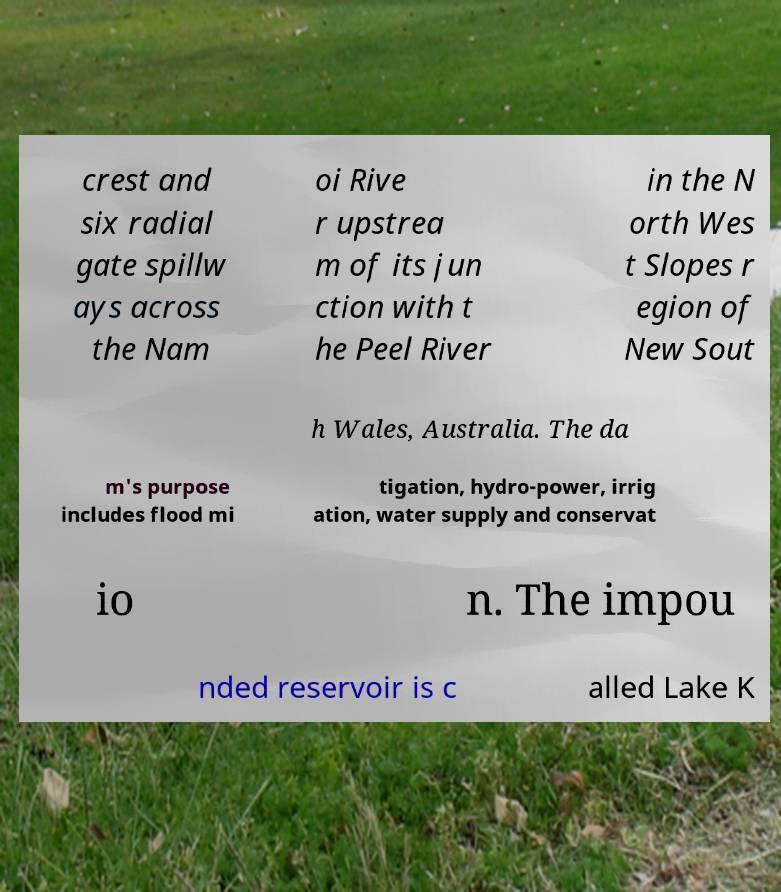Can you read and provide the text displayed in the image?This photo seems to have some interesting text. Can you extract and type it out for me? crest and six radial gate spillw ays across the Nam oi Rive r upstrea m of its jun ction with t he Peel River in the N orth Wes t Slopes r egion of New Sout h Wales, Australia. The da m's purpose includes flood mi tigation, hydro-power, irrig ation, water supply and conservat io n. The impou nded reservoir is c alled Lake K 